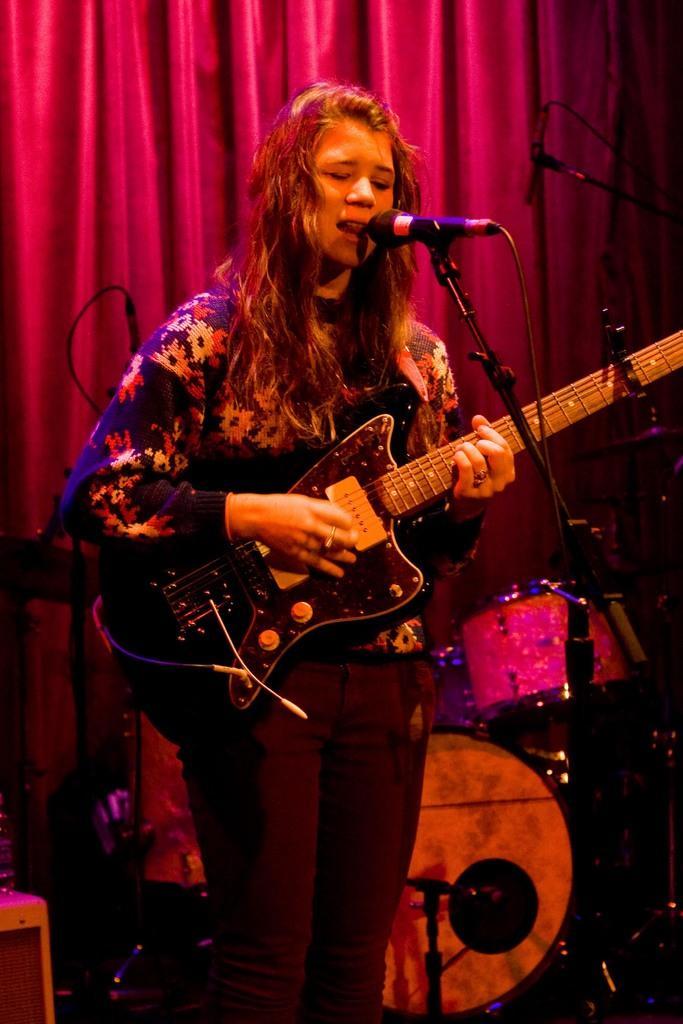Can you describe this image briefly? In this image I can see a woman is standing and I can see she is holding a guitar. In the front of her I can see a mic. Behind her, I can see a drum set, two mic stands, wires and red colour curtain. 